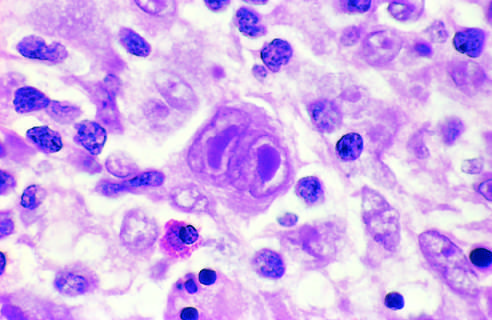s the intact basement membrane surrounded by lymphocytes, macrophages, and an eosinophil?
Answer the question using a single word or phrase. No 